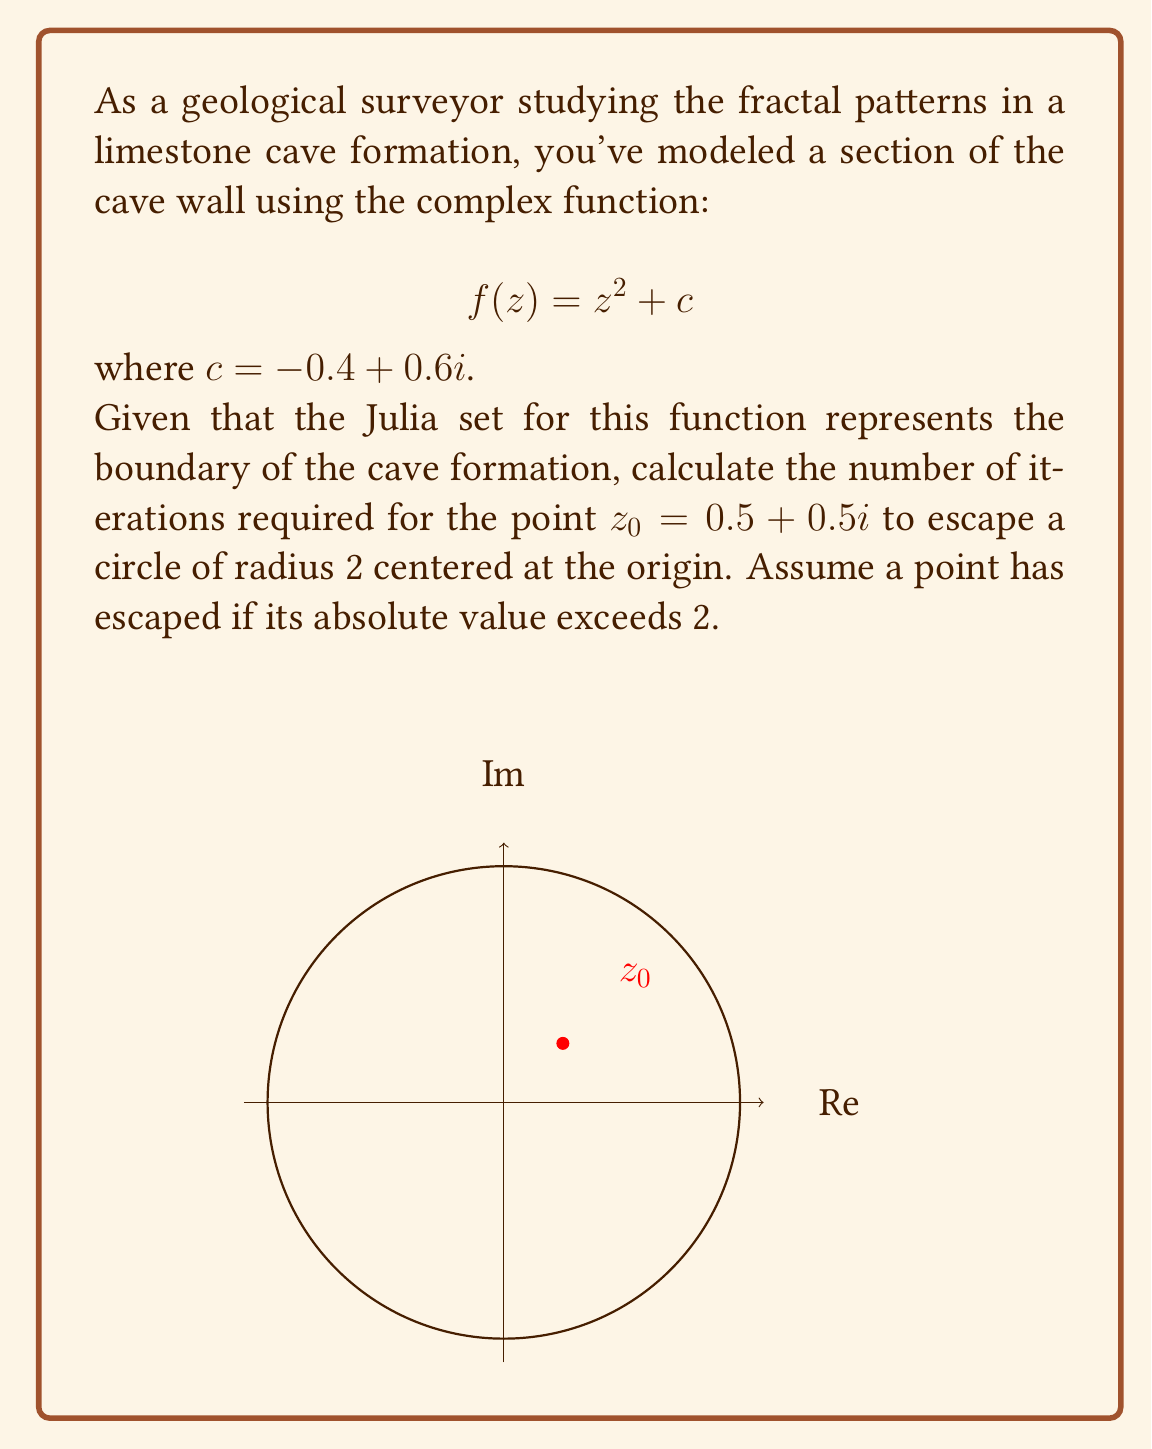Can you solve this math problem? Let's approach this step-by-step:

1) We start with $z_0 = 0.5 + 0.5i$ and $c = -0.4 + 0.6i$.

2) We'll iterate the function $f(z) = z^2 + c$ until $|z_n| > 2$ or we reach a maximum number of iterations.

3) Let's calculate each iteration:

   Iteration 1:
   $$z_1 = z_0^2 + c = (0.5 + 0.5i)^2 + (-0.4 + 0.6i)$$
   $$= (0.25 - 0.25 + 0.5i) + (-0.4 + 0.6i) = -0.15 + 1.1i$$
   $$|z_1| = \sqrt{(-0.15)^2 + 1.1^2} \approx 1.11 < 2$$

   Iteration 2:
   $$z_2 = z_1^2 + c = (-0.15 + 1.1i)^2 + (-0.4 + 0.6i)$$
   $$= (-0.9875 - 0.33i) + (-0.4 + 0.6i) = -1.3875 + 0.27i$$
   $$|z_2| = \sqrt{(-1.3875)^2 + 0.27^2} \approx 1.41 < 2$$

   Iteration 3:
   $$z_3 = z_2^2 + c = (-1.3875 + 0.27i)^2 + (-0.4 + 0.6i)$$
   $$= (1.8455 - 0.7493i) + (-0.4 + 0.6i) = 1.4455 - 0.1493i$$
   $$|z_3| = \sqrt{1.4455^2 + (-0.1493)^2} \approx 1.45 < 2$$

   Iteration 4:
   $$z_4 = z_3^2 + c = (1.4455 - 0.1493i)^2 + (-0.4 + 0.6i)$$
   $$= (2.0669 - 0.4316i) + (-0.4 + 0.6i) = 1.6669 + 0.1684i$$
   $$|z_4| = \sqrt{1.6669^2 + 0.1684^2} \approx 1.68 < 2$$

   Iteration 5:
   $$z_5 = z_4^2 + c = (1.6669 + 0.1684i)^2 + (-0.4 + 0.6i)$$
   $$= (2.7447 + 0.5613i) + (-0.4 + 0.6i) = 2.3447 + 1.1613i$$
   $$|z_5| = \sqrt{2.3447^2 + 1.1613^2} \approx 2.62 > 2$$

4) We see that after 5 iterations, the absolute value of $z_5$ exceeds 2.

Therefore, it takes 5 iterations for the point $z_0 = 0.5 + 0.5i$ to escape the circle of radius 2.
Answer: 5 iterations 